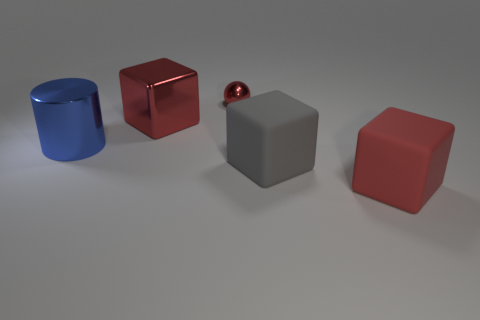What color is the metallic sphere?
Offer a terse response. Red. There is a metal thing that is the same color as the big metallic block; what size is it?
Offer a terse response. Small. There is a object that is on the left side of the big red thing behind the large blue cylinder; what number of large blue things are in front of it?
Keep it short and to the point. 0. What size is the other red thing that is the same shape as the large red rubber thing?
Provide a short and direct response. Large. Are there any other things that are the same size as the red metallic sphere?
Offer a very short reply. No. Are there fewer things that are in front of the big blue cylinder than cubes?
Ensure brevity in your answer.  Yes. Does the big gray object have the same shape as the red rubber object?
Your response must be concise. Yes. What is the color of the other large matte object that is the same shape as the gray object?
Give a very brief answer. Red. How many other big metallic cubes have the same color as the shiny cube?
Keep it short and to the point. 0. How many objects are either large things that are on the left side of the big gray thing or red spheres?
Ensure brevity in your answer.  3. 